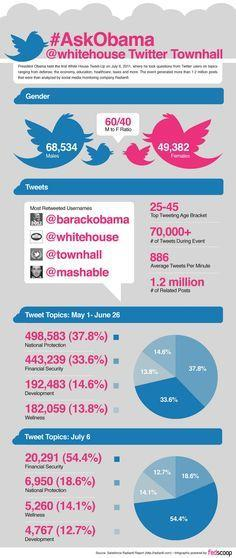Which was the most tweeted topic in July
Answer the question with a short phrase. Financial security How many tweets were on wellness from May1 - June 182,059 what position did the most tweeted topic from May 1 - June move to in July 2 